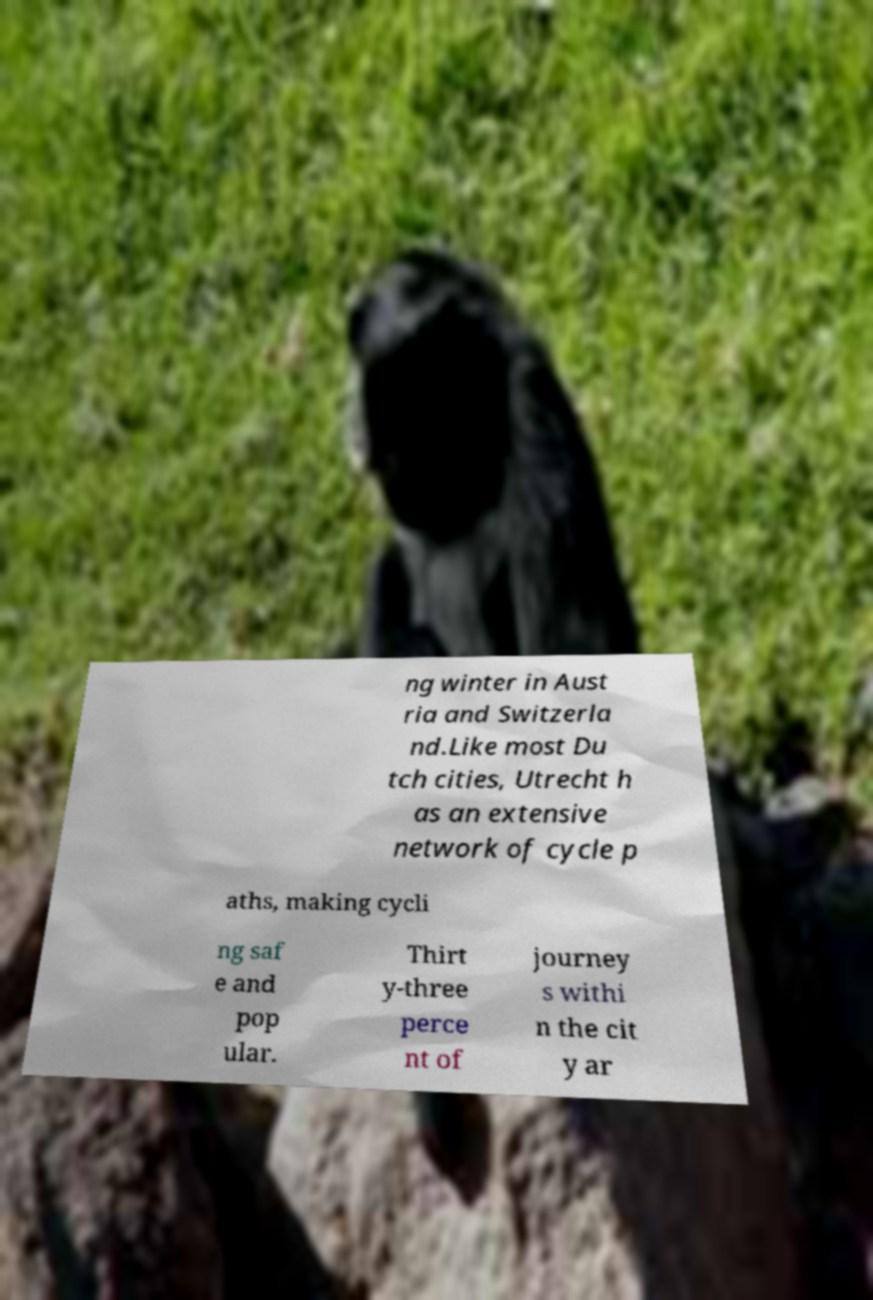I need the written content from this picture converted into text. Can you do that? ng winter in Aust ria and Switzerla nd.Like most Du tch cities, Utrecht h as an extensive network of cycle p aths, making cycli ng saf e and pop ular. Thirt y-three perce nt of journey s withi n the cit y ar 